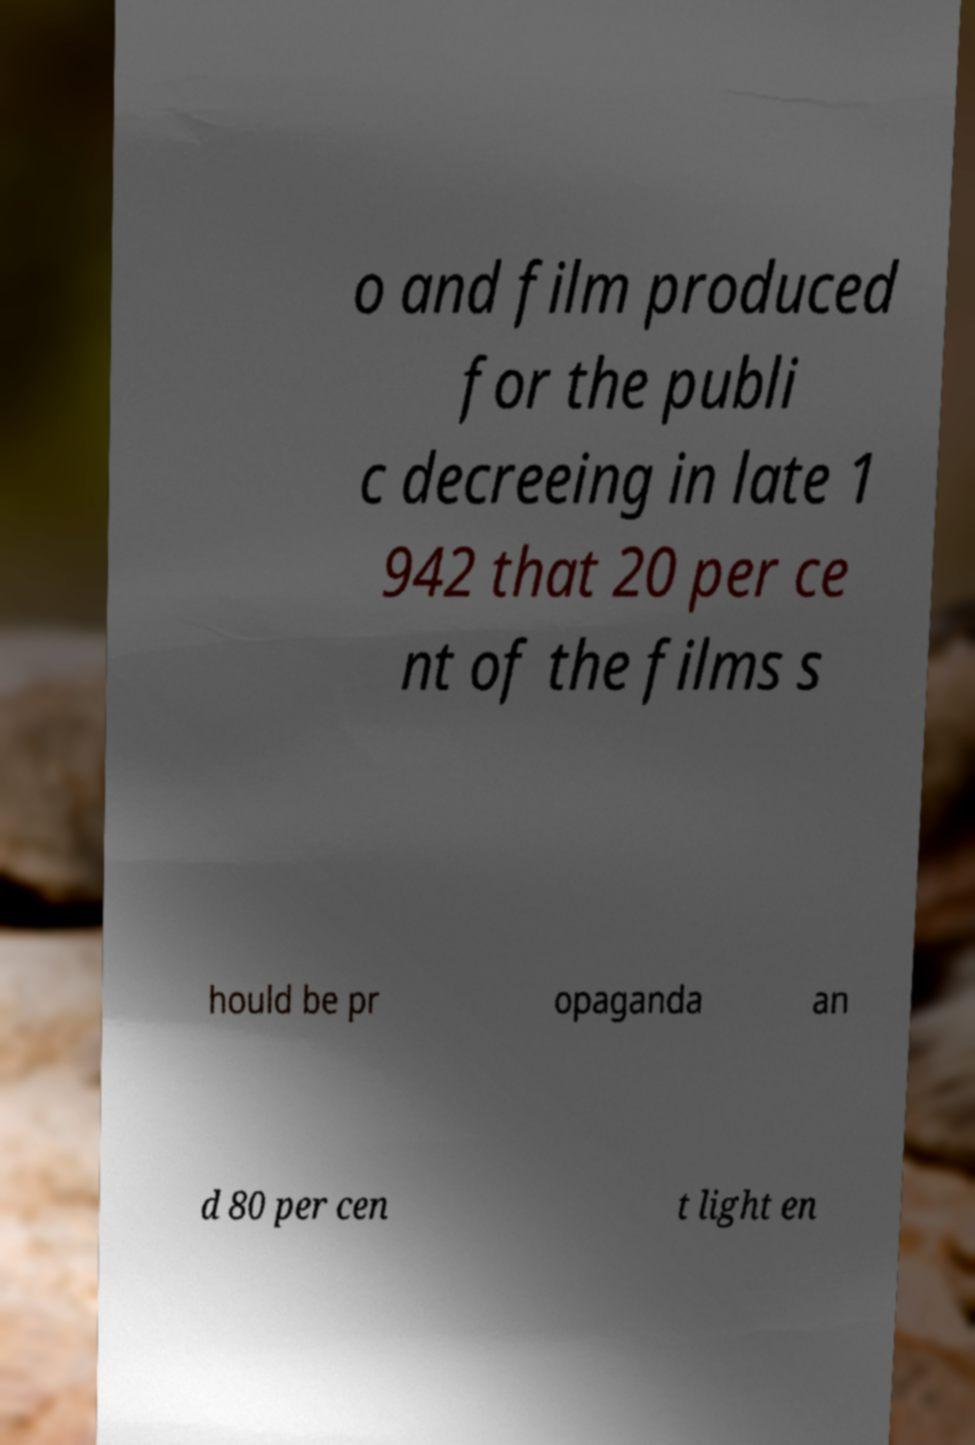I need the written content from this picture converted into text. Can you do that? o and film produced for the publi c decreeing in late 1 942 that 20 per ce nt of the films s hould be pr opaganda an d 80 per cen t light en 